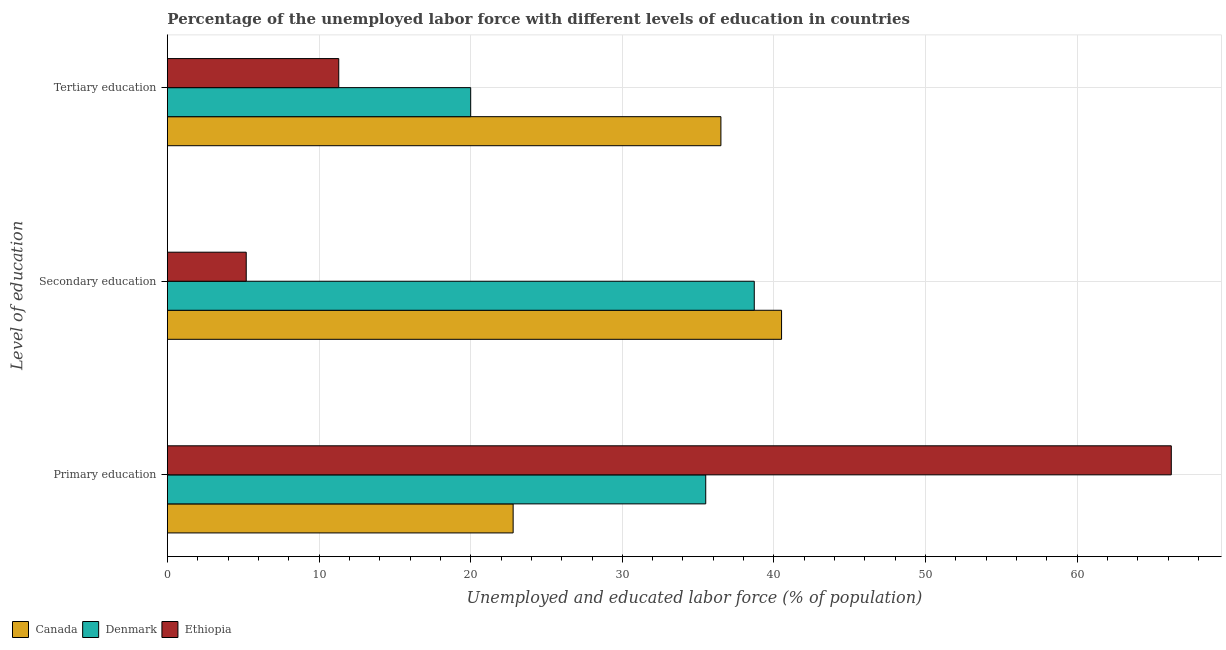How many different coloured bars are there?
Provide a short and direct response. 3. How many groups of bars are there?
Keep it short and to the point. 3. Are the number of bars per tick equal to the number of legend labels?
Provide a succinct answer. Yes. What is the label of the 2nd group of bars from the top?
Ensure brevity in your answer.  Secondary education. What is the percentage of labor force who received secondary education in Canada?
Ensure brevity in your answer.  40.5. Across all countries, what is the maximum percentage of labor force who received secondary education?
Offer a terse response. 40.5. Across all countries, what is the minimum percentage of labor force who received primary education?
Provide a short and direct response. 22.8. What is the total percentage of labor force who received primary education in the graph?
Offer a terse response. 124.5. What is the difference between the percentage of labor force who received tertiary education in Denmark and that in Canada?
Offer a terse response. -16.5. What is the difference between the percentage of labor force who received primary education in Canada and the percentage of labor force who received secondary education in Ethiopia?
Offer a very short reply. 17.6. What is the average percentage of labor force who received secondary education per country?
Your response must be concise. 28.13. In how many countries, is the percentage of labor force who received primary education greater than 32 %?
Offer a very short reply. 2. What is the ratio of the percentage of labor force who received tertiary education in Ethiopia to that in Canada?
Provide a short and direct response. 0.31. Is the percentage of labor force who received primary education in Canada less than that in Denmark?
Give a very brief answer. Yes. What is the difference between the highest and the second highest percentage of labor force who received primary education?
Make the answer very short. 30.7. What is the difference between the highest and the lowest percentage of labor force who received primary education?
Offer a terse response. 43.4. In how many countries, is the percentage of labor force who received primary education greater than the average percentage of labor force who received primary education taken over all countries?
Give a very brief answer. 1. What does the 2nd bar from the bottom in Primary education represents?
Offer a terse response. Denmark. How many bars are there?
Give a very brief answer. 9. Are all the bars in the graph horizontal?
Give a very brief answer. Yes. How many countries are there in the graph?
Give a very brief answer. 3. Does the graph contain any zero values?
Offer a terse response. No. Does the graph contain grids?
Make the answer very short. Yes. How many legend labels are there?
Offer a very short reply. 3. How are the legend labels stacked?
Ensure brevity in your answer.  Horizontal. What is the title of the graph?
Keep it short and to the point. Percentage of the unemployed labor force with different levels of education in countries. What is the label or title of the X-axis?
Your answer should be very brief. Unemployed and educated labor force (% of population). What is the label or title of the Y-axis?
Ensure brevity in your answer.  Level of education. What is the Unemployed and educated labor force (% of population) in Canada in Primary education?
Offer a very short reply. 22.8. What is the Unemployed and educated labor force (% of population) of Denmark in Primary education?
Provide a short and direct response. 35.5. What is the Unemployed and educated labor force (% of population) of Ethiopia in Primary education?
Your answer should be very brief. 66.2. What is the Unemployed and educated labor force (% of population) of Canada in Secondary education?
Keep it short and to the point. 40.5. What is the Unemployed and educated labor force (% of population) of Denmark in Secondary education?
Ensure brevity in your answer.  38.7. What is the Unemployed and educated labor force (% of population) of Ethiopia in Secondary education?
Your answer should be compact. 5.2. What is the Unemployed and educated labor force (% of population) in Canada in Tertiary education?
Your answer should be very brief. 36.5. What is the Unemployed and educated labor force (% of population) in Ethiopia in Tertiary education?
Keep it short and to the point. 11.3. Across all Level of education, what is the maximum Unemployed and educated labor force (% of population) in Canada?
Your answer should be compact. 40.5. Across all Level of education, what is the maximum Unemployed and educated labor force (% of population) in Denmark?
Offer a terse response. 38.7. Across all Level of education, what is the maximum Unemployed and educated labor force (% of population) of Ethiopia?
Offer a very short reply. 66.2. Across all Level of education, what is the minimum Unemployed and educated labor force (% of population) in Canada?
Your answer should be compact. 22.8. Across all Level of education, what is the minimum Unemployed and educated labor force (% of population) of Denmark?
Your response must be concise. 20. Across all Level of education, what is the minimum Unemployed and educated labor force (% of population) of Ethiopia?
Your answer should be compact. 5.2. What is the total Unemployed and educated labor force (% of population) in Canada in the graph?
Offer a very short reply. 99.8. What is the total Unemployed and educated labor force (% of population) of Denmark in the graph?
Your answer should be very brief. 94.2. What is the total Unemployed and educated labor force (% of population) in Ethiopia in the graph?
Ensure brevity in your answer.  82.7. What is the difference between the Unemployed and educated labor force (% of population) in Canada in Primary education and that in Secondary education?
Offer a terse response. -17.7. What is the difference between the Unemployed and educated labor force (% of population) in Denmark in Primary education and that in Secondary education?
Provide a short and direct response. -3.2. What is the difference between the Unemployed and educated labor force (% of population) in Canada in Primary education and that in Tertiary education?
Provide a succinct answer. -13.7. What is the difference between the Unemployed and educated labor force (% of population) in Ethiopia in Primary education and that in Tertiary education?
Provide a short and direct response. 54.9. What is the difference between the Unemployed and educated labor force (% of population) of Canada in Primary education and the Unemployed and educated labor force (% of population) of Denmark in Secondary education?
Offer a terse response. -15.9. What is the difference between the Unemployed and educated labor force (% of population) in Canada in Primary education and the Unemployed and educated labor force (% of population) in Ethiopia in Secondary education?
Provide a short and direct response. 17.6. What is the difference between the Unemployed and educated labor force (% of population) in Denmark in Primary education and the Unemployed and educated labor force (% of population) in Ethiopia in Secondary education?
Offer a very short reply. 30.3. What is the difference between the Unemployed and educated labor force (% of population) of Canada in Primary education and the Unemployed and educated labor force (% of population) of Ethiopia in Tertiary education?
Ensure brevity in your answer.  11.5. What is the difference between the Unemployed and educated labor force (% of population) of Denmark in Primary education and the Unemployed and educated labor force (% of population) of Ethiopia in Tertiary education?
Ensure brevity in your answer.  24.2. What is the difference between the Unemployed and educated labor force (% of population) of Canada in Secondary education and the Unemployed and educated labor force (% of population) of Denmark in Tertiary education?
Provide a short and direct response. 20.5. What is the difference between the Unemployed and educated labor force (% of population) of Canada in Secondary education and the Unemployed and educated labor force (% of population) of Ethiopia in Tertiary education?
Offer a terse response. 29.2. What is the difference between the Unemployed and educated labor force (% of population) in Denmark in Secondary education and the Unemployed and educated labor force (% of population) in Ethiopia in Tertiary education?
Give a very brief answer. 27.4. What is the average Unemployed and educated labor force (% of population) in Canada per Level of education?
Ensure brevity in your answer.  33.27. What is the average Unemployed and educated labor force (% of population) in Denmark per Level of education?
Offer a very short reply. 31.4. What is the average Unemployed and educated labor force (% of population) in Ethiopia per Level of education?
Offer a very short reply. 27.57. What is the difference between the Unemployed and educated labor force (% of population) in Canada and Unemployed and educated labor force (% of population) in Denmark in Primary education?
Ensure brevity in your answer.  -12.7. What is the difference between the Unemployed and educated labor force (% of population) of Canada and Unemployed and educated labor force (% of population) of Ethiopia in Primary education?
Offer a terse response. -43.4. What is the difference between the Unemployed and educated labor force (% of population) of Denmark and Unemployed and educated labor force (% of population) of Ethiopia in Primary education?
Offer a very short reply. -30.7. What is the difference between the Unemployed and educated labor force (% of population) in Canada and Unemployed and educated labor force (% of population) in Denmark in Secondary education?
Offer a terse response. 1.8. What is the difference between the Unemployed and educated labor force (% of population) in Canada and Unemployed and educated labor force (% of population) in Ethiopia in Secondary education?
Your answer should be compact. 35.3. What is the difference between the Unemployed and educated labor force (% of population) of Denmark and Unemployed and educated labor force (% of population) of Ethiopia in Secondary education?
Make the answer very short. 33.5. What is the difference between the Unemployed and educated labor force (% of population) of Canada and Unemployed and educated labor force (% of population) of Ethiopia in Tertiary education?
Provide a short and direct response. 25.2. What is the ratio of the Unemployed and educated labor force (% of population) of Canada in Primary education to that in Secondary education?
Your response must be concise. 0.56. What is the ratio of the Unemployed and educated labor force (% of population) in Denmark in Primary education to that in Secondary education?
Your answer should be very brief. 0.92. What is the ratio of the Unemployed and educated labor force (% of population) in Ethiopia in Primary education to that in Secondary education?
Your answer should be compact. 12.73. What is the ratio of the Unemployed and educated labor force (% of population) of Canada in Primary education to that in Tertiary education?
Provide a short and direct response. 0.62. What is the ratio of the Unemployed and educated labor force (% of population) in Denmark in Primary education to that in Tertiary education?
Keep it short and to the point. 1.77. What is the ratio of the Unemployed and educated labor force (% of population) of Ethiopia in Primary education to that in Tertiary education?
Keep it short and to the point. 5.86. What is the ratio of the Unemployed and educated labor force (% of population) of Canada in Secondary education to that in Tertiary education?
Make the answer very short. 1.11. What is the ratio of the Unemployed and educated labor force (% of population) in Denmark in Secondary education to that in Tertiary education?
Give a very brief answer. 1.94. What is the ratio of the Unemployed and educated labor force (% of population) of Ethiopia in Secondary education to that in Tertiary education?
Your response must be concise. 0.46. What is the difference between the highest and the second highest Unemployed and educated labor force (% of population) of Denmark?
Ensure brevity in your answer.  3.2. What is the difference between the highest and the second highest Unemployed and educated labor force (% of population) of Ethiopia?
Ensure brevity in your answer.  54.9. What is the difference between the highest and the lowest Unemployed and educated labor force (% of population) in Canada?
Your answer should be very brief. 17.7. 